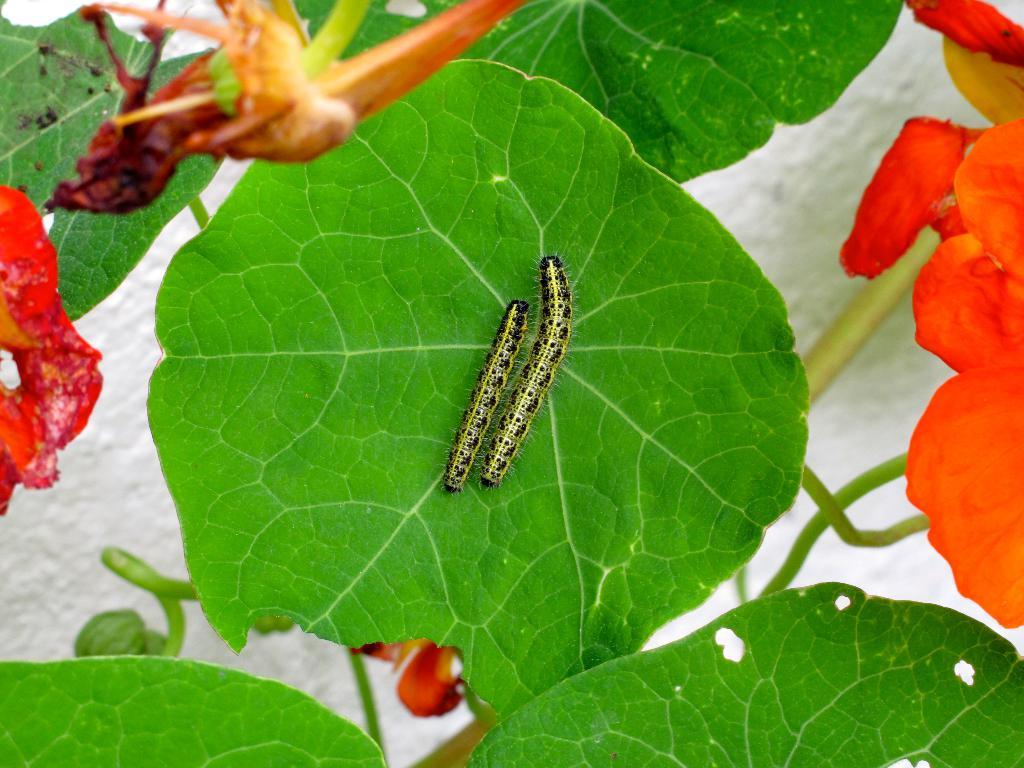What type of plant life can be seen in the image? There are leaves and flowers in the image. Are there any living organisms visible in the image? Yes, there are worms in the image. How many babies are playing chess in the image? There are no babies or chess games present in the image. What type of hat is worn by the worm in the image? There are no hats visible in the image, as it features leaves, flowers, and worms. 